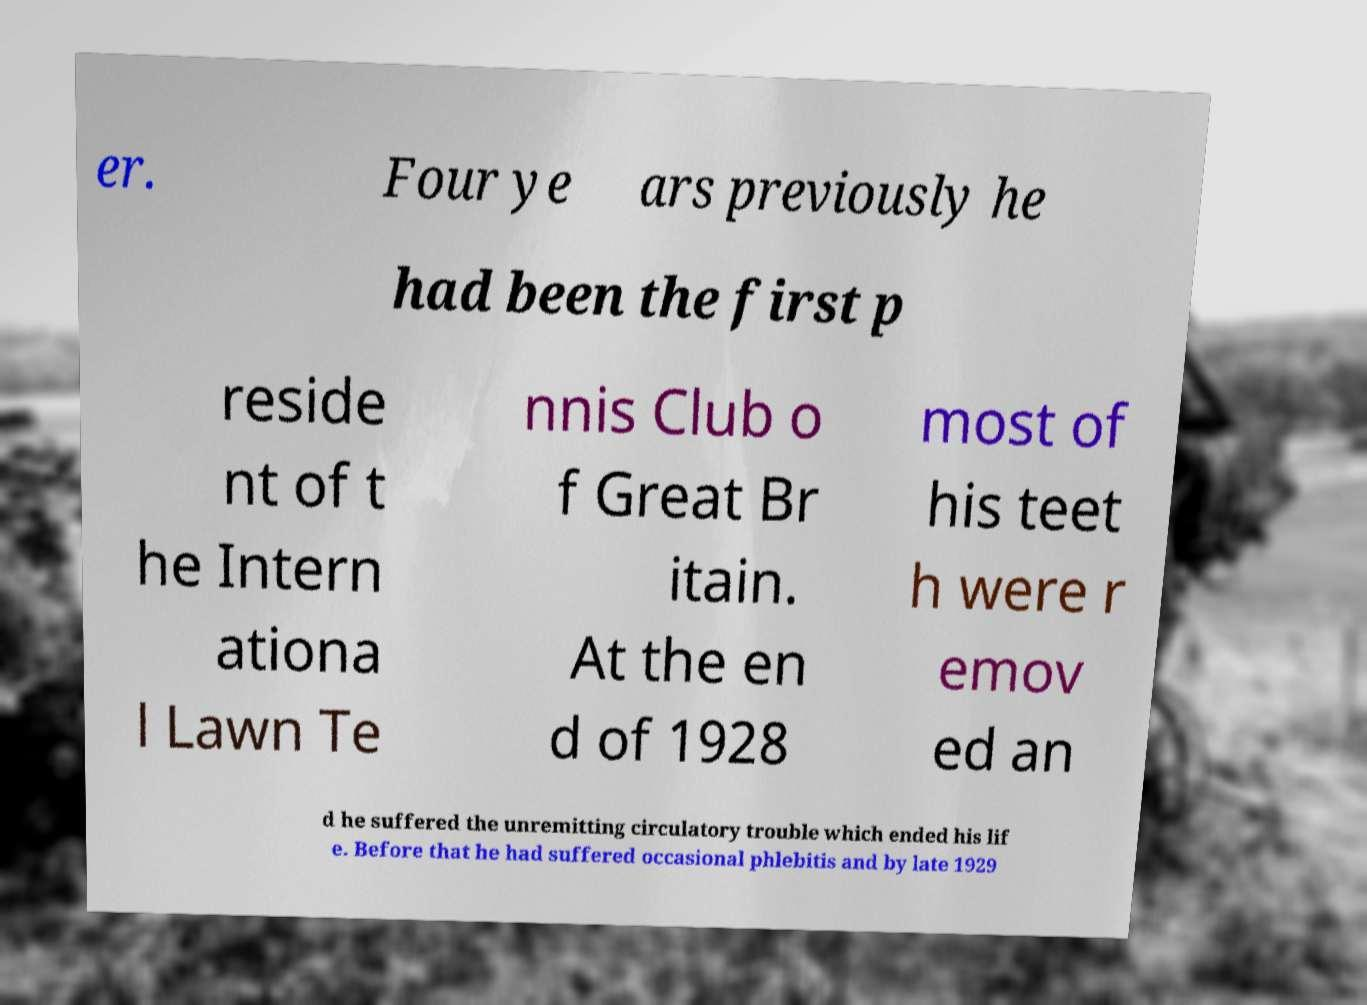There's text embedded in this image that I need extracted. Can you transcribe it verbatim? er. Four ye ars previously he had been the first p reside nt of t he Intern ationa l Lawn Te nnis Club o f Great Br itain. At the en d of 1928 most of his teet h were r emov ed an d he suffered the unremitting circulatory trouble which ended his lif e. Before that he had suffered occasional phlebitis and by late 1929 